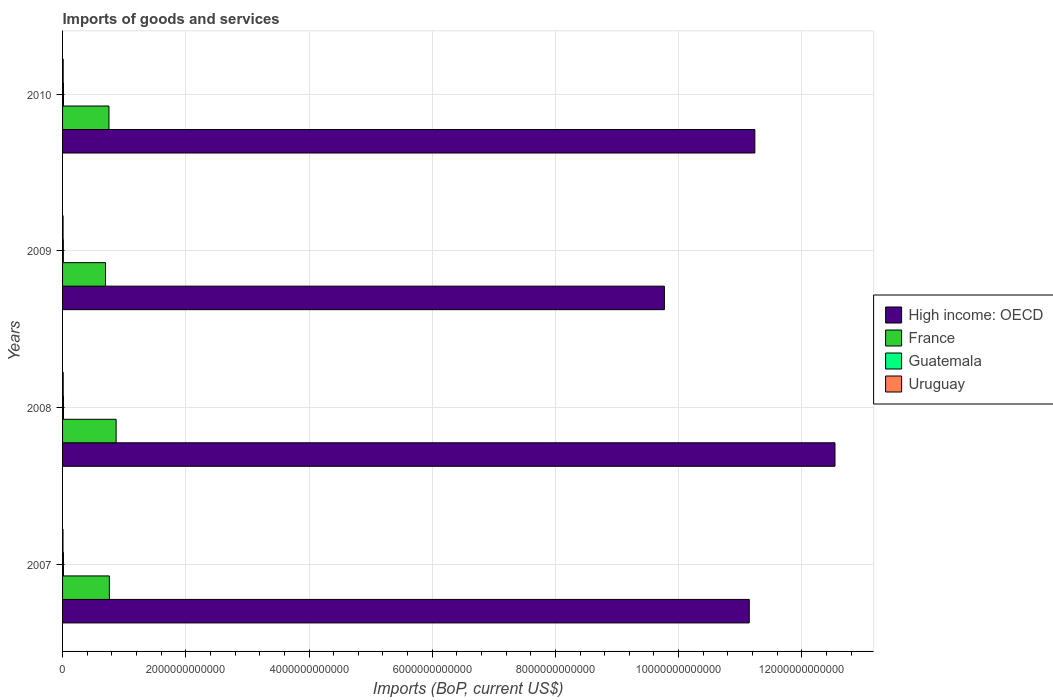How many groups of bars are there?
Your answer should be very brief. 4. Are the number of bars on each tick of the Y-axis equal?
Your answer should be compact. Yes. What is the label of the 1st group of bars from the top?
Your response must be concise. 2010. In how many cases, is the number of bars for a given year not equal to the number of legend labels?
Your response must be concise. 0. What is the amount spent on imports in Uruguay in 2010?
Keep it short and to the point. 1.01e+1. Across all years, what is the maximum amount spent on imports in High income: OECD?
Make the answer very short. 1.25e+13. Across all years, what is the minimum amount spent on imports in Uruguay?
Ensure brevity in your answer.  6.78e+09. What is the total amount spent on imports in High income: OECD in the graph?
Offer a very short reply. 4.47e+13. What is the difference between the amount spent on imports in Guatemala in 2007 and that in 2009?
Give a very brief answer. 1.74e+09. What is the difference between the amount spent on imports in France in 2010 and the amount spent on imports in Guatemala in 2007?
Your response must be concise. 7.39e+11. What is the average amount spent on imports in Guatemala per year?
Offer a very short reply. 1.45e+1. In the year 2008, what is the difference between the amount spent on imports in Uruguay and amount spent on imports in High income: OECD?
Your answer should be compact. -1.25e+13. In how many years, is the amount spent on imports in High income: OECD greater than 9200000000000 US$?
Your answer should be compact. 4. What is the ratio of the amount spent on imports in France in 2008 to that in 2009?
Your response must be concise. 1.25. Is the amount spent on imports in Uruguay in 2007 less than that in 2010?
Make the answer very short. Yes. Is the difference between the amount spent on imports in Uruguay in 2008 and 2010 greater than the difference between the amount spent on imports in High income: OECD in 2008 and 2010?
Keep it short and to the point. No. What is the difference between the highest and the second highest amount spent on imports in Guatemala?
Ensure brevity in your answer.  2.51e+08. What is the difference between the highest and the lowest amount spent on imports in France?
Keep it short and to the point. 1.72e+11. Is it the case that in every year, the sum of the amount spent on imports in Guatemala and amount spent on imports in Uruguay is greater than the sum of amount spent on imports in High income: OECD and amount spent on imports in France?
Your answer should be very brief. No. What does the 1st bar from the bottom in 2009 represents?
Your response must be concise. High income: OECD. Is it the case that in every year, the sum of the amount spent on imports in Guatemala and amount spent on imports in High income: OECD is greater than the amount spent on imports in Uruguay?
Ensure brevity in your answer.  Yes. How many bars are there?
Keep it short and to the point. 16. What is the difference between two consecutive major ticks on the X-axis?
Your response must be concise. 2.00e+12. Does the graph contain grids?
Ensure brevity in your answer.  Yes. Where does the legend appear in the graph?
Offer a terse response. Center right. What is the title of the graph?
Make the answer very short. Imports of goods and services. What is the label or title of the X-axis?
Your answer should be very brief. Imports (BoP, current US$). What is the Imports (BoP, current US$) of High income: OECD in 2007?
Your answer should be compact. 1.11e+13. What is the Imports (BoP, current US$) in France in 2007?
Keep it short and to the point. 7.60e+11. What is the Imports (BoP, current US$) of Guatemala in 2007?
Make the answer very short. 1.45e+1. What is the Imports (BoP, current US$) of Uruguay in 2007?
Your answer should be very brief. 6.78e+09. What is the Imports (BoP, current US$) of High income: OECD in 2008?
Provide a succinct answer. 1.25e+13. What is the Imports (BoP, current US$) of France in 2008?
Provide a short and direct response. 8.69e+11. What is the Imports (BoP, current US$) of Guatemala in 2008?
Ensure brevity in your answer.  1.55e+1. What is the Imports (BoP, current US$) of Uruguay in 2008?
Provide a short and direct response. 1.03e+1. What is the Imports (BoP, current US$) in High income: OECD in 2009?
Provide a succinct answer. 9.77e+12. What is the Imports (BoP, current US$) in France in 2009?
Offer a very short reply. 6.97e+11. What is the Imports (BoP, current US$) in Guatemala in 2009?
Provide a short and direct response. 1.28e+1. What is the Imports (BoP, current US$) of Uruguay in 2009?
Provide a short and direct response. 8.19e+09. What is the Imports (BoP, current US$) in High income: OECD in 2010?
Keep it short and to the point. 1.12e+13. What is the Imports (BoP, current US$) in France in 2010?
Make the answer very short. 7.53e+11. What is the Imports (BoP, current US$) in Guatemala in 2010?
Offer a terse response. 1.52e+1. What is the Imports (BoP, current US$) of Uruguay in 2010?
Your answer should be compact. 1.01e+1. Across all years, what is the maximum Imports (BoP, current US$) of High income: OECD?
Provide a short and direct response. 1.25e+13. Across all years, what is the maximum Imports (BoP, current US$) of France?
Your answer should be compact. 8.69e+11. Across all years, what is the maximum Imports (BoP, current US$) in Guatemala?
Your response must be concise. 1.55e+1. Across all years, what is the maximum Imports (BoP, current US$) of Uruguay?
Make the answer very short. 1.03e+1. Across all years, what is the minimum Imports (BoP, current US$) in High income: OECD?
Make the answer very short. 9.77e+12. Across all years, what is the minimum Imports (BoP, current US$) in France?
Keep it short and to the point. 6.97e+11. Across all years, what is the minimum Imports (BoP, current US$) in Guatemala?
Offer a terse response. 1.28e+1. Across all years, what is the minimum Imports (BoP, current US$) in Uruguay?
Keep it short and to the point. 6.78e+09. What is the total Imports (BoP, current US$) in High income: OECD in the graph?
Your answer should be compact. 4.47e+13. What is the total Imports (BoP, current US$) in France in the graph?
Your answer should be compact. 3.08e+12. What is the total Imports (BoP, current US$) of Guatemala in the graph?
Make the answer very short. 5.80e+1. What is the total Imports (BoP, current US$) in Uruguay in the graph?
Ensure brevity in your answer.  3.54e+1. What is the difference between the Imports (BoP, current US$) in High income: OECD in 2007 and that in 2008?
Give a very brief answer. -1.39e+12. What is the difference between the Imports (BoP, current US$) of France in 2007 and that in 2008?
Offer a terse response. -1.09e+11. What is the difference between the Imports (BoP, current US$) in Guatemala in 2007 and that in 2008?
Offer a terse response. -9.53e+08. What is the difference between the Imports (BoP, current US$) in Uruguay in 2007 and that in 2008?
Offer a very short reply. -3.56e+09. What is the difference between the Imports (BoP, current US$) in High income: OECD in 2007 and that in 2009?
Give a very brief answer. 1.38e+12. What is the difference between the Imports (BoP, current US$) of France in 2007 and that in 2009?
Your response must be concise. 6.23e+1. What is the difference between the Imports (BoP, current US$) in Guatemala in 2007 and that in 2009?
Offer a terse response. 1.74e+09. What is the difference between the Imports (BoP, current US$) of Uruguay in 2007 and that in 2009?
Your response must be concise. -1.41e+09. What is the difference between the Imports (BoP, current US$) in High income: OECD in 2007 and that in 2010?
Make the answer very short. -9.06e+1. What is the difference between the Imports (BoP, current US$) of France in 2007 and that in 2010?
Provide a succinct answer. 6.70e+09. What is the difference between the Imports (BoP, current US$) of Guatemala in 2007 and that in 2010?
Make the answer very short. -7.02e+08. What is the difference between the Imports (BoP, current US$) of Uruguay in 2007 and that in 2010?
Provide a short and direct response. -3.31e+09. What is the difference between the Imports (BoP, current US$) in High income: OECD in 2008 and that in 2009?
Offer a terse response. 2.77e+12. What is the difference between the Imports (BoP, current US$) of France in 2008 and that in 2009?
Offer a very short reply. 1.72e+11. What is the difference between the Imports (BoP, current US$) in Guatemala in 2008 and that in 2009?
Offer a terse response. 2.69e+09. What is the difference between the Imports (BoP, current US$) of Uruguay in 2008 and that in 2009?
Give a very brief answer. 2.14e+09. What is the difference between the Imports (BoP, current US$) in High income: OECD in 2008 and that in 2010?
Give a very brief answer. 1.30e+12. What is the difference between the Imports (BoP, current US$) in France in 2008 and that in 2010?
Give a very brief answer. 1.16e+11. What is the difference between the Imports (BoP, current US$) in Guatemala in 2008 and that in 2010?
Your answer should be compact. 2.51e+08. What is the difference between the Imports (BoP, current US$) of Uruguay in 2008 and that in 2010?
Make the answer very short. 2.44e+08. What is the difference between the Imports (BoP, current US$) of High income: OECD in 2009 and that in 2010?
Your answer should be compact. -1.47e+12. What is the difference between the Imports (BoP, current US$) of France in 2009 and that in 2010?
Offer a very short reply. -5.56e+1. What is the difference between the Imports (BoP, current US$) of Guatemala in 2009 and that in 2010?
Give a very brief answer. -2.44e+09. What is the difference between the Imports (BoP, current US$) in Uruguay in 2009 and that in 2010?
Your answer should be very brief. -1.90e+09. What is the difference between the Imports (BoP, current US$) in High income: OECD in 2007 and the Imports (BoP, current US$) in France in 2008?
Provide a short and direct response. 1.03e+13. What is the difference between the Imports (BoP, current US$) of High income: OECD in 2007 and the Imports (BoP, current US$) of Guatemala in 2008?
Your answer should be very brief. 1.11e+13. What is the difference between the Imports (BoP, current US$) of High income: OECD in 2007 and the Imports (BoP, current US$) of Uruguay in 2008?
Keep it short and to the point. 1.11e+13. What is the difference between the Imports (BoP, current US$) in France in 2007 and the Imports (BoP, current US$) in Guatemala in 2008?
Keep it short and to the point. 7.44e+11. What is the difference between the Imports (BoP, current US$) of France in 2007 and the Imports (BoP, current US$) of Uruguay in 2008?
Offer a terse response. 7.49e+11. What is the difference between the Imports (BoP, current US$) of Guatemala in 2007 and the Imports (BoP, current US$) of Uruguay in 2008?
Provide a succinct answer. 4.18e+09. What is the difference between the Imports (BoP, current US$) of High income: OECD in 2007 and the Imports (BoP, current US$) of France in 2009?
Keep it short and to the point. 1.04e+13. What is the difference between the Imports (BoP, current US$) of High income: OECD in 2007 and the Imports (BoP, current US$) of Guatemala in 2009?
Your answer should be compact. 1.11e+13. What is the difference between the Imports (BoP, current US$) in High income: OECD in 2007 and the Imports (BoP, current US$) in Uruguay in 2009?
Ensure brevity in your answer.  1.11e+13. What is the difference between the Imports (BoP, current US$) of France in 2007 and the Imports (BoP, current US$) of Guatemala in 2009?
Provide a short and direct response. 7.47e+11. What is the difference between the Imports (BoP, current US$) of France in 2007 and the Imports (BoP, current US$) of Uruguay in 2009?
Offer a very short reply. 7.52e+11. What is the difference between the Imports (BoP, current US$) of Guatemala in 2007 and the Imports (BoP, current US$) of Uruguay in 2009?
Your answer should be very brief. 6.32e+09. What is the difference between the Imports (BoP, current US$) in High income: OECD in 2007 and the Imports (BoP, current US$) in France in 2010?
Give a very brief answer. 1.04e+13. What is the difference between the Imports (BoP, current US$) in High income: OECD in 2007 and the Imports (BoP, current US$) in Guatemala in 2010?
Ensure brevity in your answer.  1.11e+13. What is the difference between the Imports (BoP, current US$) in High income: OECD in 2007 and the Imports (BoP, current US$) in Uruguay in 2010?
Keep it short and to the point. 1.11e+13. What is the difference between the Imports (BoP, current US$) of France in 2007 and the Imports (BoP, current US$) of Guatemala in 2010?
Offer a terse response. 7.45e+11. What is the difference between the Imports (BoP, current US$) in France in 2007 and the Imports (BoP, current US$) in Uruguay in 2010?
Your response must be concise. 7.50e+11. What is the difference between the Imports (BoP, current US$) of Guatemala in 2007 and the Imports (BoP, current US$) of Uruguay in 2010?
Your response must be concise. 4.42e+09. What is the difference between the Imports (BoP, current US$) in High income: OECD in 2008 and the Imports (BoP, current US$) in France in 2009?
Provide a succinct answer. 1.18e+13. What is the difference between the Imports (BoP, current US$) of High income: OECD in 2008 and the Imports (BoP, current US$) of Guatemala in 2009?
Make the answer very short. 1.25e+13. What is the difference between the Imports (BoP, current US$) of High income: OECD in 2008 and the Imports (BoP, current US$) of Uruguay in 2009?
Give a very brief answer. 1.25e+13. What is the difference between the Imports (BoP, current US$) of France in 2008 and the Imports (BoP, current US$) of Guatemala in 2009?
Your response must be concise. 8.56e+11. What is the difference between the Imports (BoP, current US$) in France in 2008 and the Imports (BoP, current US$) in Uruguay in 2009?
Provide a short and direct response. 8.61e+11. What is the difference between the Imports (BoP, current US$) in Guatemala in 2008 and the Imports (BoP, current US$) in Uruguay in 2009?
Your response must be concise. 7.27e+09. What is the difference between the Imports (BoP, current US$) in High income: OECD in 2008 and the Imports (BoP, current US$) in France in 2010?
Offer a very short reply. 1.18e+13. What is the difference between the Imports (BoP, current US$) in High income: OECD in 2008 and the Imports (BoP, current US$) in Guatemala in 2010?
Your answer should be very brief. 1.25e+13. What is the difference between the Imports (BoP, current US$) of High income: OECD in 2008 and the Imports (BoP, current US$) of Uruguay in 2010?
Keep it short and to the point. 1.25e+13. What is the difference between the Imports (BoP, current US$) in France in 2008 and the Imports (BoP, current US$) in Guatemala in 2010?
Ensure brevity in your answer.  8.54e+11. What is the difference between the Imports (BoP, current US$) of France in 2008 and the Imports (BoP, current US$) of Uruguay in 2010?
Ensure brevity in your answer.  8.59e+11. What is the difference between the Imports (BoP, current US$) in Guatemala in 2008 and the Imports (BoP, current US$) in Uruguay in 2010?
Provide a succinct answer. 5.38e+09. What is the difference between the Imports (BoP, current US$) of High income: OECD in 2009 and the Imports (BoP, current US$) of France in 2010?
Give a very brief answer. 9.02e+12. What is the difference between the Imports (BoP, current US$) of High income: OECD in 2009 and the Imports (BoP, current US$) of Guatemala in 2010?
Provide a short and direct response. 9.75e+12. What is the difference between the Imports (BoP, current US$) of High income: OECD in 2009 and the Imports (BoP, current US$) of Uruguay in 2010?
Provide a short and direct response. 9.76e+12. What is the difference between the Imports (BoP, current US$) in France in 2009 and the Imports (BoP, current US$) in Guatemala in 2010?
Provide a succinct answer. 6.82e+11. What is the difference between the Imports (BoP, current US$) of France in 2009 and the Imports (BoP, current US$) of Uruguay in 2010?
Make the answer very short. 6.87e+11. What is the difference between the Imports (BoP, current US$) of Guatemala in 2009 and the Imports (BoP, current US$) of Uruguay in 2010?
Make the answer very short. 2.69e+09. What is the average Imports (BoP, current US$) of High income: OECD per year?
Your answer should be very brief. 1.12e+13. What is the average Imports (BoP, current US$) of France per year?
Offer a terse response. 7.70e+11. What is the average Imports (BoP, current US$) of Guatemala per year?
Offer a terse response. 1.45e+1. What is the average Imports (BoP, current US$) in Uruguay per year?
Your response must be concise. 8.85e+09. In the year 2007, what is the difference between the Imports (BoP, current US$) in High income: OECD and Imports (BoP, current US$) in France?
Keep it short and to the point. 1.04e+13. In the year 2007, what is the difference between the Imports (BoP, current US$) of High income: OECD and Imports (BoP, current US$) of Guatemala?
Offer a very short reply. 1.11e+13. In the year 2007, what is the difference between the Imports (BoP, current US$) in High income: OECD and Imports (BoP, current US$) in Uruguay?
Offer a very short reply. 1.11e+13. In the year 2007, what is the difference between the Imports (BoP, current US$) in France and Imports (BoP, current US$) in Guatemala?
Make the answer very short. 7.45e+11. In the year 2007, what is the difference between the Imports (BoP, current US$) in France and Imports (BoP, current US$) in Uruguay?
Provide a succinct answer. 7.53e+11. In the year 2007, what is the difference between the Imports (BoP, current US$) in Guatemala and Imports (BoP, current US$) in Uruguay?
Keep it short and to the point. 7.74e+09. In the year 2008, what is the difference between the Imports (BoP, current US$) of High income: OECD and Imports (BoP, current US$) of France?
Provide a short and direct response. 1.17e+13. In the year 2008, what is the difference between the Imports (BoP, current US$) in High income: OECD and Imports (BoP, current US$) in Guatemala?
Ensure brevity in your answer.  1.25e+13. In the year 2008, what is the difference between the Imports (BoP, current US$) in High income: OECD and Imports (BoP, current US$) in Uruguay?
Ensure brevity in your answer.  1.25e+13. In the year 2008, what is the difference between the Imports (BoP, current US$) in France and Imports (BoP, current US$) in Guatemala?
Keep it short and to the point. 8.54e+11. In the year 2008, what is the difference between the Imports (BoP, current US$) in France and Imports (BoP, current US$) in Uruguay?
Your answer should be compact. 8.59e+11. In the year 2008, what is the difference between the Imports (BoP, current US$) of Guatemala and Imports (BoP, current US$) of Uruguay?
Offer a terse response. 5.13e+09. In the year 2009, what is the difference between the Imports (BoP, current US$) of High income: OECD and Imports (BoP, current US$) of France?
Offer a very short reply. 9.07e+12. In the year 2009, what is the difference between the Imports (BoP, current US$) of High income: OECD and Imports (BoP, current US$) of Guatemala?
Provide a succinct answer. 9.76e+12. In the year 2009, what is the difference between the Imports (BoP, current US$) in High income: OECD and Imports (BoP, current US$) in Uruguay?
Your answer should be very brief. 9.76e+12. In the year 2009, what is the difference between the Imports (BoP, current US$) in France and Imports (BoP, current US$) in Guatemala?
Give a very brief answer. 6.85e+11. In the year 2009, what is the difference between the Imports (BoP, current US$) of France and Imports (BoP, current US$) of Uruguay?
Make the answer very short. 6.89e+11. In the year 2009, what is the difference between the Imports (BoP, current US$) in Guatemala and Imports (BoP, current US$) in Uruguay?
Offer a terse response. 4.58e+09. In the year 2010, what is the difference between the Imports (BoP, current US$) in High income: OECD and Imports (BoP, current US$) in France?
Offer a terse response. 1.05e+13. In the year 2010, what is the difference between the Imports (BoP, current US$) of High income: OECD and Imports (BoP, current US$) of Guatemala?
Keep it short and to the point. 1.12e+13. In the year 2010, what is the difference between the Imports (BoP, current US$) of High income: OECD and Imports (BoP, current US$) of Uruguay?
Offer a terse response. 1.12e+13. In the year 2010, what is the difference between the Imports (BoP, current US$) in France and Imports (BoP, current US$) in Guatemala?
Keep it short and to the point. 7.38e+11. In the year 2010, what is the difference between the Imports (BoP, current US$) in France and Imports (BoP, current US$) in Uruguay?
Your response must be concise. 7.43e+11. In the year 2010, what is the difference between the Imports (BoP, current US$) of Guatemala and Imports (BoP, current US$) of Uruguay?
Offer a very short reply. 5.13e+09. What is the ratio of the Imports (BoP, current US$) of High income: OECD in 2007 to that in 2008?
Ensure brevity in your answer.  0.89. What is the ratio of the Imports (BoP, current US$) in France in 2007 to that in 2008?
Give a very brief answer. 0.87. What is the ratio of the Imports (BoP, current US$) of Guatemala in 2007 to that in 2008?
Make the answer very short. 0.94. What is the ratio of the Imports (BoP, current US$) in Uruguay in 2007 to that in 2008?
Keep it short and to the point. 0.66. What is the ratio of the Imports (BoP, current US$) of High income: OECD in 2007 to that in 2009?
Give a very brief answer. 1.14. What is the ratio of the Imports (BoP, current US$) in France in 2007 to that in 2009?
Your answer should be compact. 1.09. What is the ratio of the Imports (BoP, current US$) of Guatemala in 2007 to that in 2009?
Provide a succinct answer. 1.14. What is the ratio of the Imports (BoP, current US$) in Uruguay in 2007 to that in 2009?
Ensure brevity in your answer.  0.83. What is the ratio of the Imports (BoP, current US$) of France in 2007 to that in 2010?
Make the answer very short. 1.01. What is the ratio of the Imports (BoP, current US$) in Guatemala in 2007 to that in 2010?
Provide a succinct answer. 0.95. What is the ratio of the Imports (BoP, current US$) in Uruguay in 2007 to that in 2010?
Offer a very short reply. 0.67. What is the ratio of the Imports (BoP, current US$) of High income: OECD in 2008 to that in 2009?
Offer a terse response. 1.28. What is the ratio of the Imports (BoP, current US$) of France in 2008 to that in 2009?
Give a very brief answer. 1.25. What is the ratio of the Imports (BoP, current US$) in Guatemala in 2008 to that in 2009?
Ensure brevity in your answer.  1.21. What is the ratio of the Imports (BoP, current US$) in Uruguay in 2008 to that in 2009?
Your answer should be very brief. 1.26. What is the ratio of the Imports (BoP, current US$) of High income: OECD in 2008 to that in 2010?
Your response must be concise. 1.12. What is the ratio of the Imports (BoP, current US$) of France in 2008 to that in 2010?
Offer a very short reply. 1.15. What is the ratio of the Imports (BoP, current US$) in Guatemala in 2008 to that in 2010?
Provide a short and direct response. 1.02. What is the ratio of the Imports (BoP, current US$) of Uruguay in 2008 to that in 2010?
Ensure brevity in your answer.  1.02. What is the ratio of the Imports (BoP, current US$) of High income: OECD in 2009 to that in 2010?
Your response must be concise. 0.87. What is the ratio of the Imports (BoP, current US$) of France in 2009 to that in 2010?
Ensure brevity in your answer.  0.93. What is the ratio of the Imports (BoP, current US$) of Guatemala in 2009 to that in 2010?
Your answer should be very brief. 0.84. What is the ratio of the Imports (BoP, current US$) in Uruguay in 2009 to that in 2010?
Ensure brevity in your answer.  0.81. What is the difference between the highest and the second highest Imports (BoP, current US$) of High income: OECD?
Give a very brief answer. 1.30e+12. What is the difference between the highest and the second highest Imports (BoP, current US$) in France?
Provide a succinct answer. 1.09e+11. What is the difference between the highest and the second highest Imports (BoP, current US$) of Guatemala?
Offer a terse response. 2.51e+08. What is the difference between the highest and the second highest Imports (BoP, current US$) of Uruguay?
Make the answer very short. 2.44e+08. What is the difference between the highest and the lowest Imports (BoP, current US$) of High income: OECD?
Your response must be concise. 2.77e+12. What is the difference between the highest and the lowest Imports (BoP, current US$) of France?
Make the answer very short. 1.72e+11. What is the difference between the highest and the lowest Imports (BoP, current US$) of Guatemala?
Give a very brief answer. 2.69e+09. What is the difference between the highest and the lowest Imports (BoP, current US$) in Uruguay?
Provide a succinct answer. 3.56e+09. 